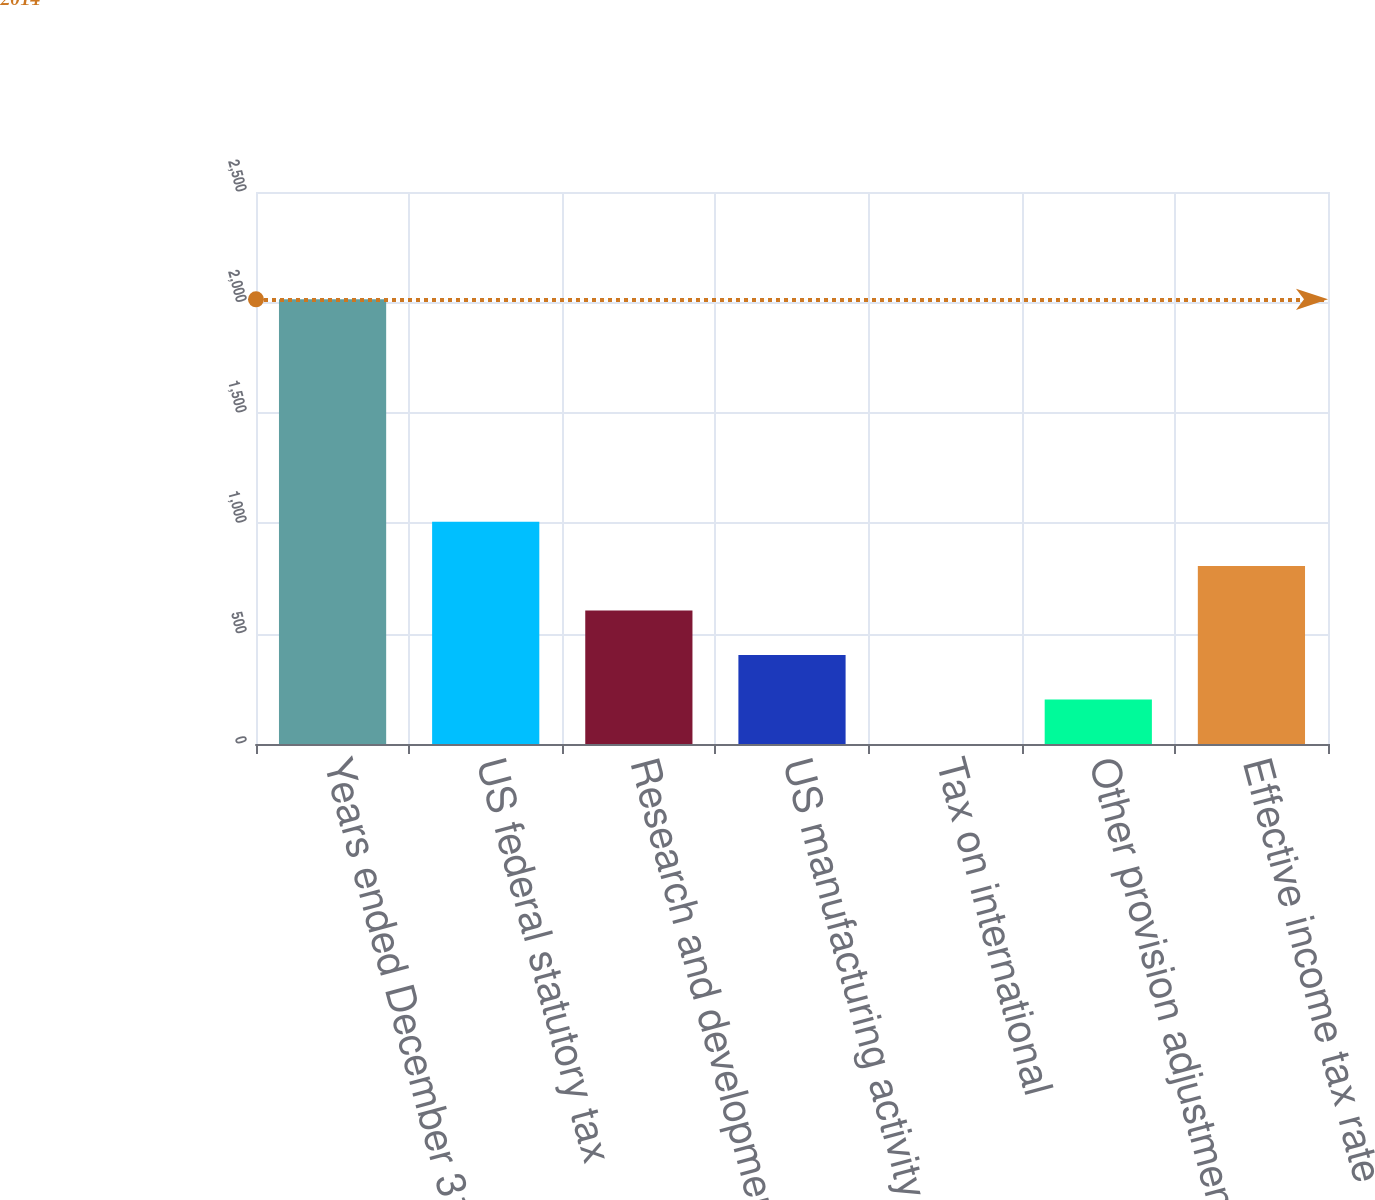Convert chart to OTSL. <chart><loc_0><loc_0><loc_500><loc_500><bar_chart><fcel>Years ended December 31<fcel>US federal statutory tax<fcel>Research and development<fcel>US manufacturing activity tax<fcel>Tax on international<fcel>Other provision adjustments<fcel>Effective income tax rate<nl><fcel>2014<fcel>1007.1<fcel>604.34<fcel>402.96<fcel>0.2<fcel>201.58<fcel>805.72<nl></chart> 